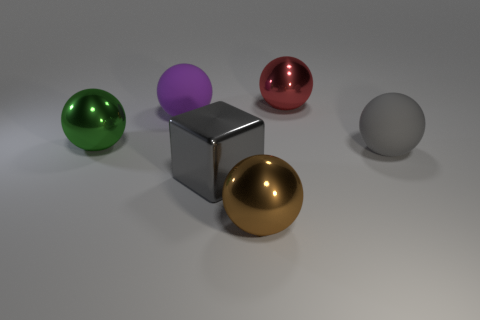How many big blocks are behind the large green sphere?
Your response must be concise. 0. Is there a gray metal thing of the same size as the cube?
Your answer should be compact. No. There is a big thing that is to the left of the big rubber ball that is to the left of the big gray block; what is its color?
Provide a succinct answer. Green. How many shiny things are in front of the big purple object and behind the big gray rubber sphere?
Give a very brief answer. 1. What number of cyan things are the same shape as the purple matte object?
Provide a succinct answer. 0. Does the large red ball have the same material as the green object?
Provide a short and direct response. Yes. There is a large metallic object behind the matte ball that is on the left side of the big red sphere; what shape is it?
Offer a very short reply. Sphere. How many things are to the right of the matte thing that is to the right of the large gray cube?
Your response must be concise. 0. What is the material of the big thing that is in front of the green shiny object and to the left of the brown metal sphere?
Keep it short and to the point. Metal. What is the shape of the red metal thing that is the same size as the gray shiny block?
Give a very brief answer. Sphere. 